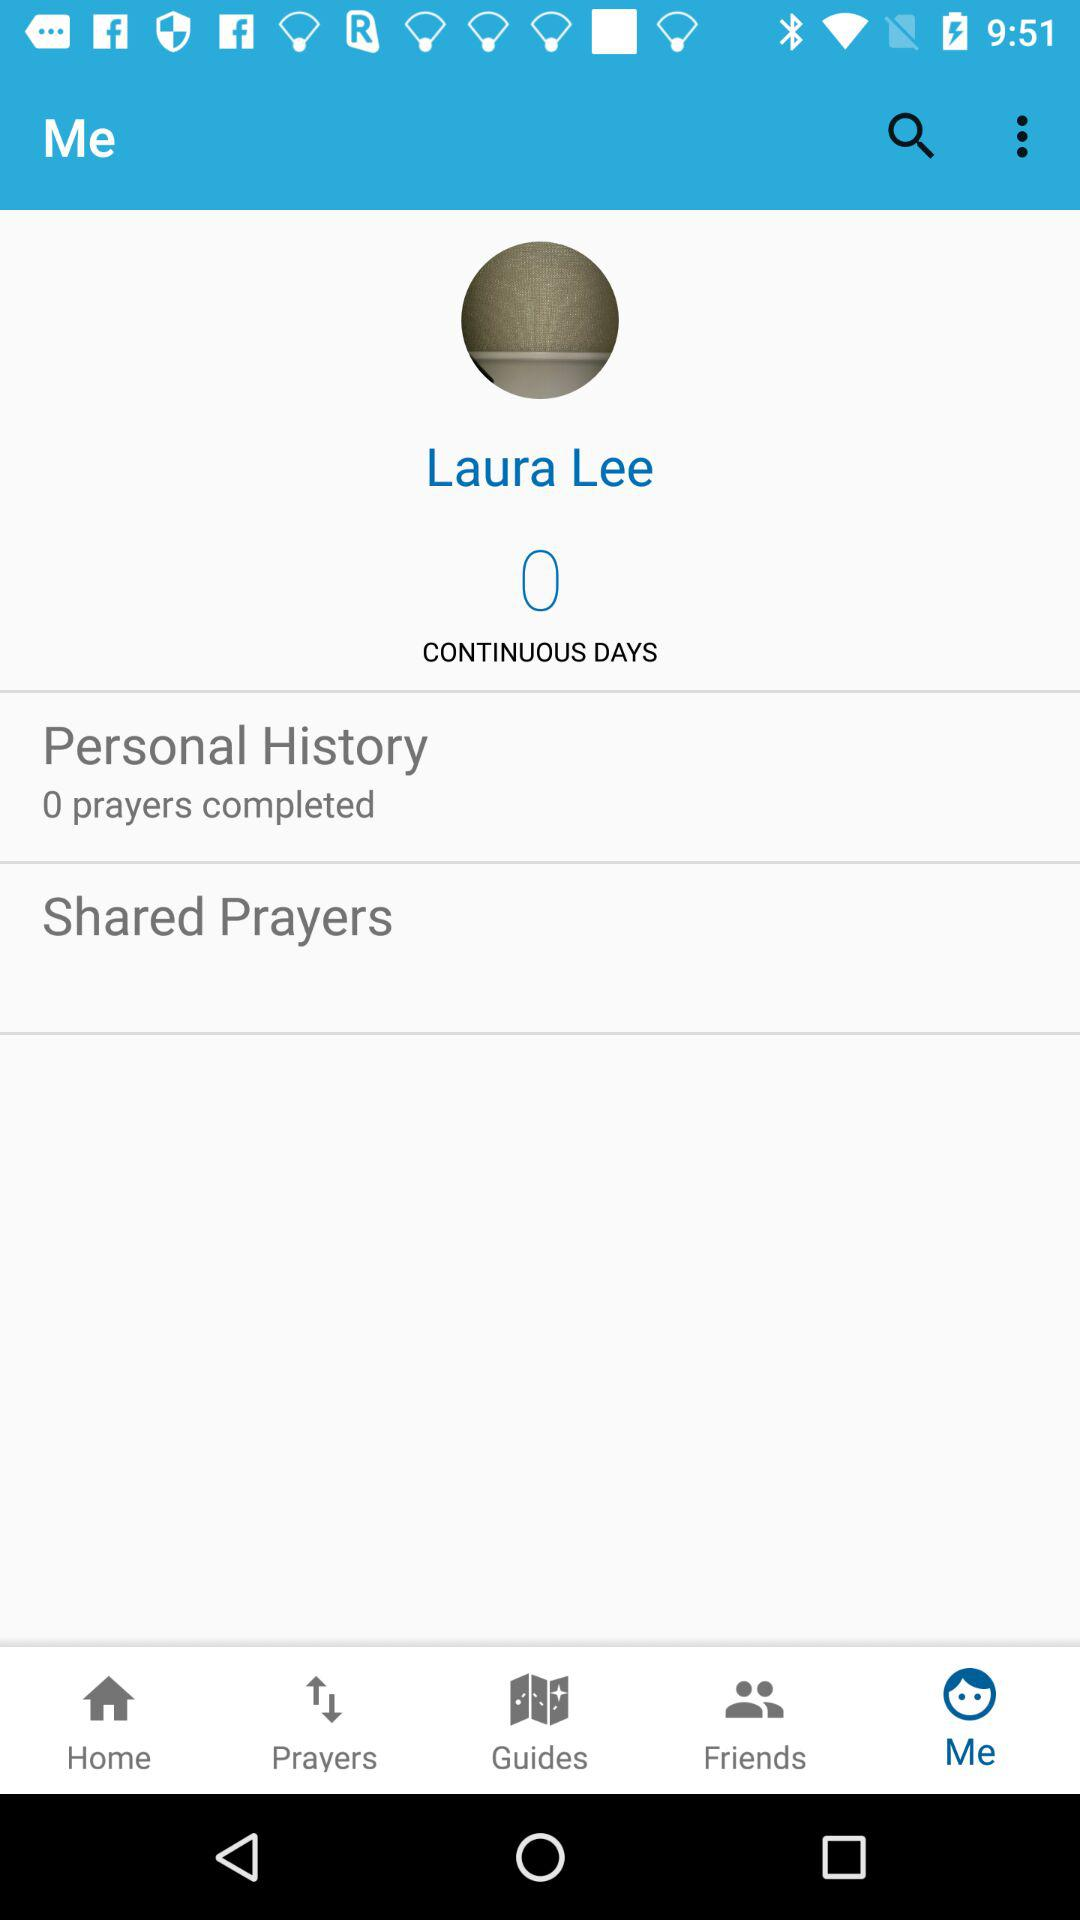How many days have passed since Laura Lee last prayed?
Answer the question using a single word or phrase. 0 